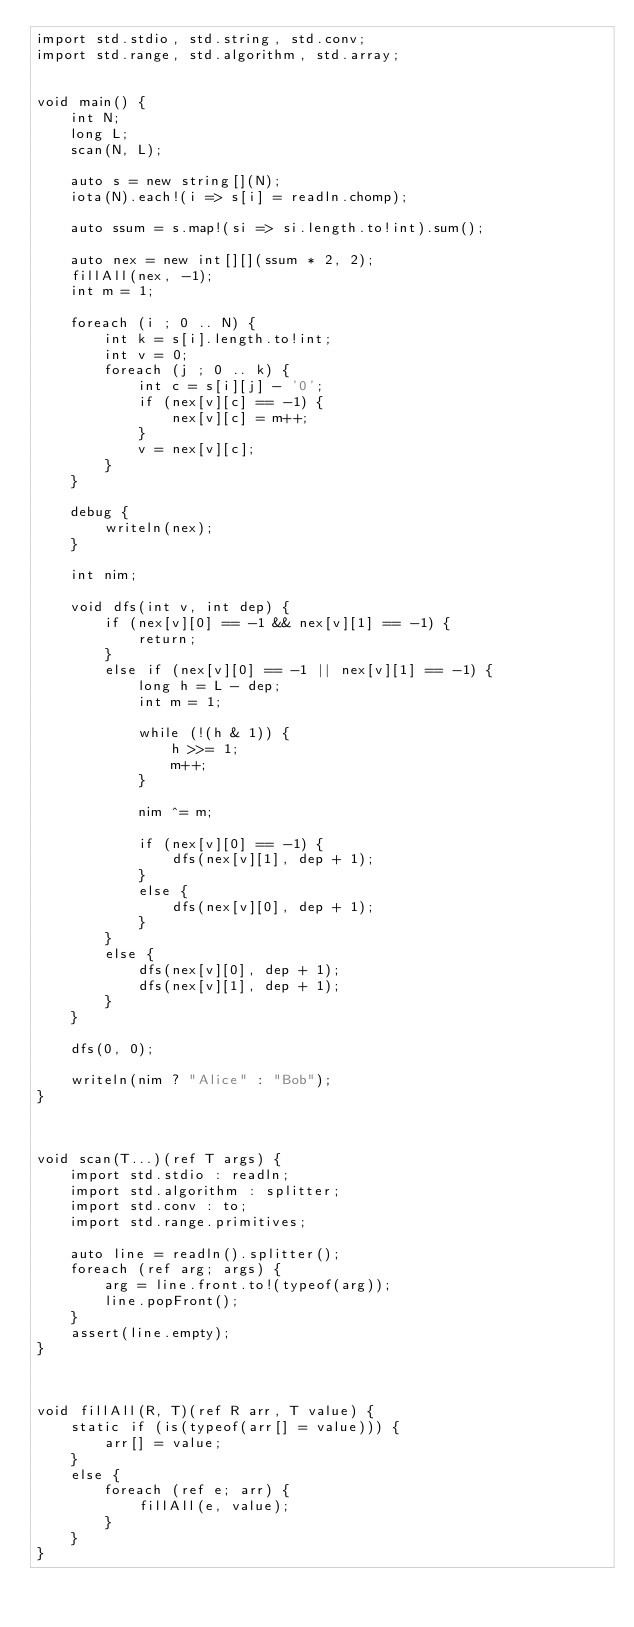<code> <loc_0><loc_0><loc_500><loc_500><_D_>import std.stdio, std.string, std.conv;
import std.range, std.algorithm, std.array;


void main() {
    int N;
    long L;
    scan(N, L);

    auto s = new string[](N);
    iota(N).each!(i => s[i] = readln.chomp);

    auto ssum = s.map!(si => si.length.to!int).sum();

    auto nex = new int[][](ssum * 2, 2);
    fillAll(nex, -1);
    int m = 1;

    foreach (i ; 0 .. N) {
        int k = s[i].length.to!int;
        int v = 0;
        foreach (j ; 0 .. k) {
            int c = s[i][j] - '0';
            if (nex[v][c] == -1) {
                nex[v][c] = m++;
            }
            v = nex[v][c];
        }
    }

    debug {
        writeln(nex);
    }

    int nim;

    void dfs(int v, int dep) {
        if (nex[v][0] == -1 && nex[v][1] == -1) {
            return;
        }
        else if (nex[v][0] == -1 || nex[v][1] == -1) {
            long h = L - dep;
            int m = 1;

            while (!(h & 1)) {
                h >>= 1;
                m++;
            }

            nim ^= m;

            if (nex[v][0] == -1) {
                dfs(nex[v][1], dep + 1);
            }
            else {
                dfs(nex[v][0], dep + 1);
            }
        }
        else {
            dfs(nex[v][0], dep + 1);
            dfs(nex[v][1], dep + 1);
        }
    }

    dfs(0, 0);

    writeln(nim ? "Alice" : "Bob");
}



void scan(T...)(ref T args) {
    import std.stdio : readln;
    import std.algorithm : splitter;
    import std.conv : to;
    import std.range.primitives;

    auto line = readln().splitter();
    foreach (ref arg; args) {
        arg = line.front.to!(typeof(arg));
        line.popFront();
    }
    assert(line.empty);
}



void fillAll(R, T)(ref R arr, T value) {
    static if (is(typeof(arr[] = value))) {
        arr[] = value;
    }
    else {
        foreach (ref e; arr) {
            fillAll(e, value);
        }
    }
}
</code> 